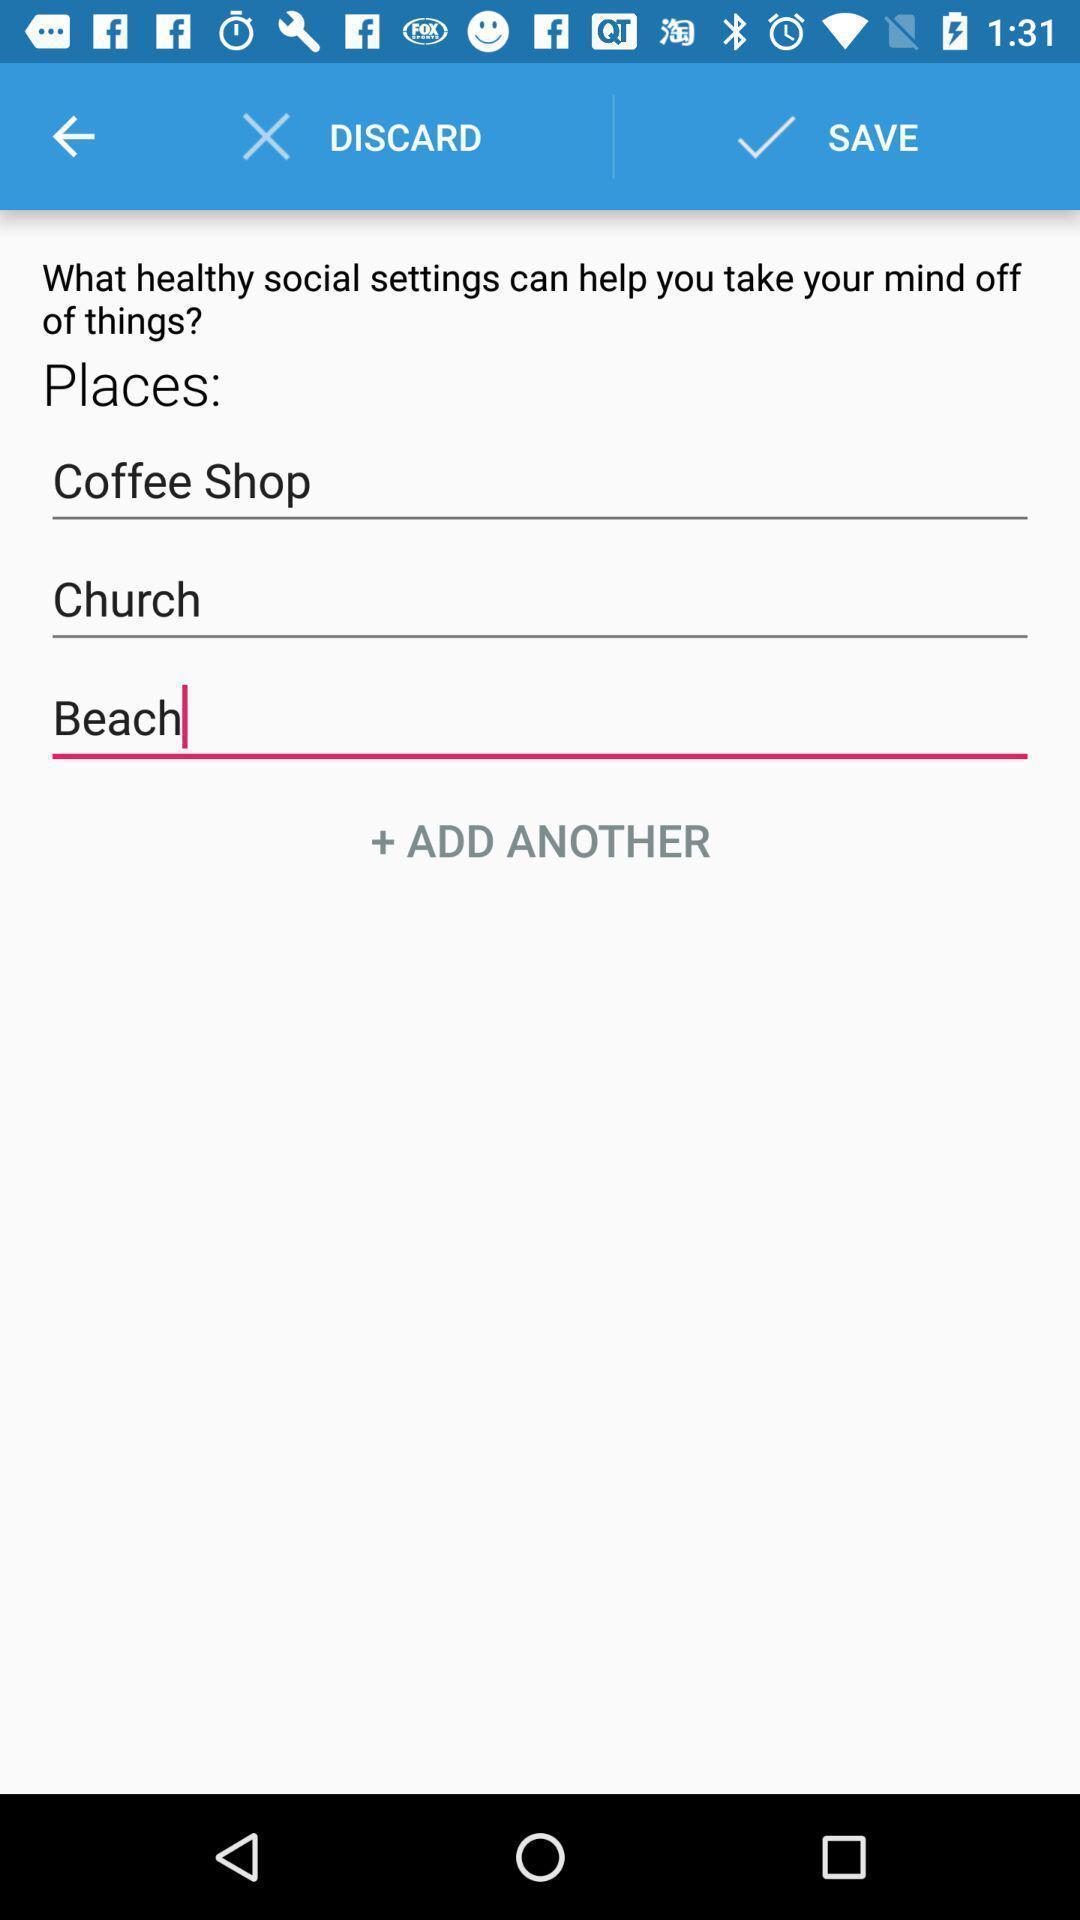Describe the key features of this screenshot. Page showing options for choosing a place. 